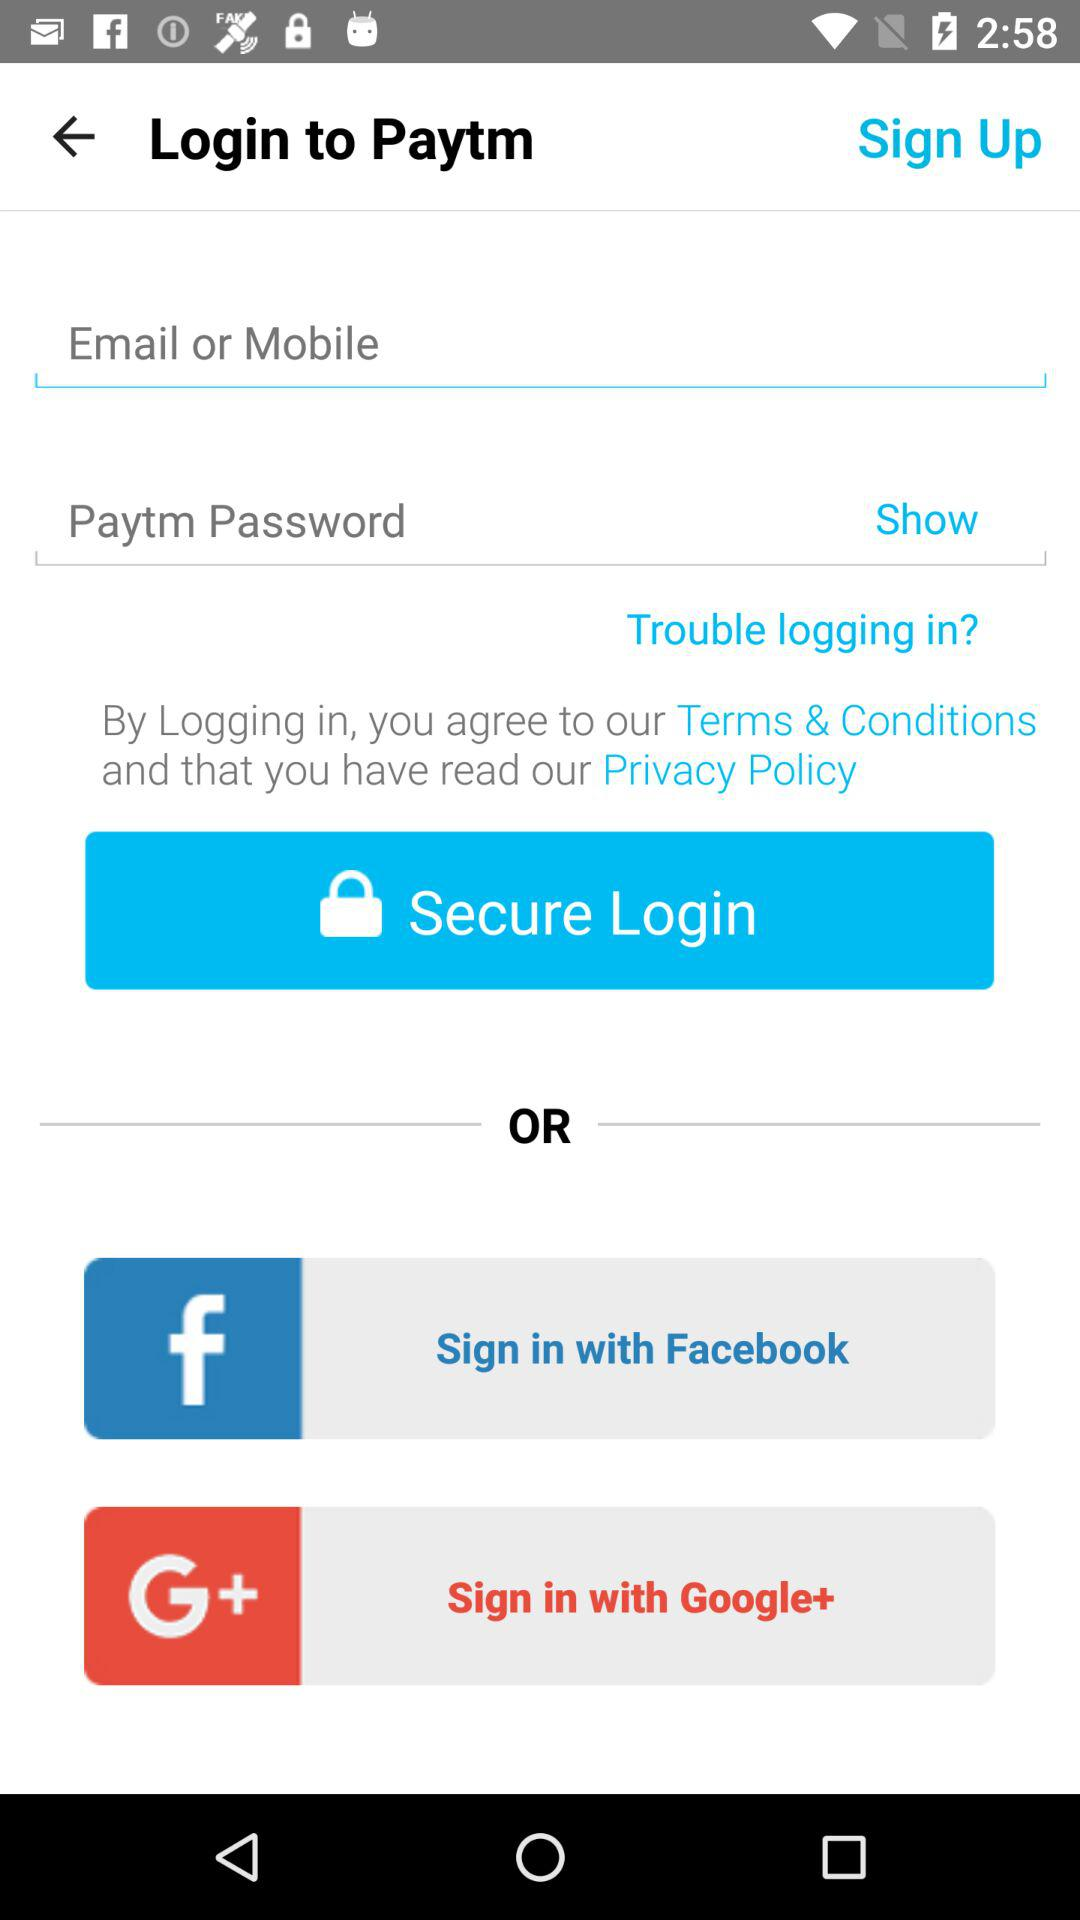What are the different options available to sign in? The options are "Facebook" and "Google+". 